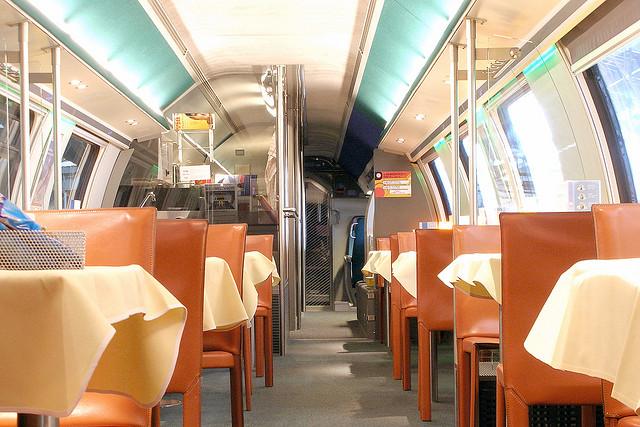What color are the chairs?
Write a very short answer. Orange. Is anyone sitting at a table?
Give a very brief answer. No. What color are the tablecloths?
Be succinct. Cream. 